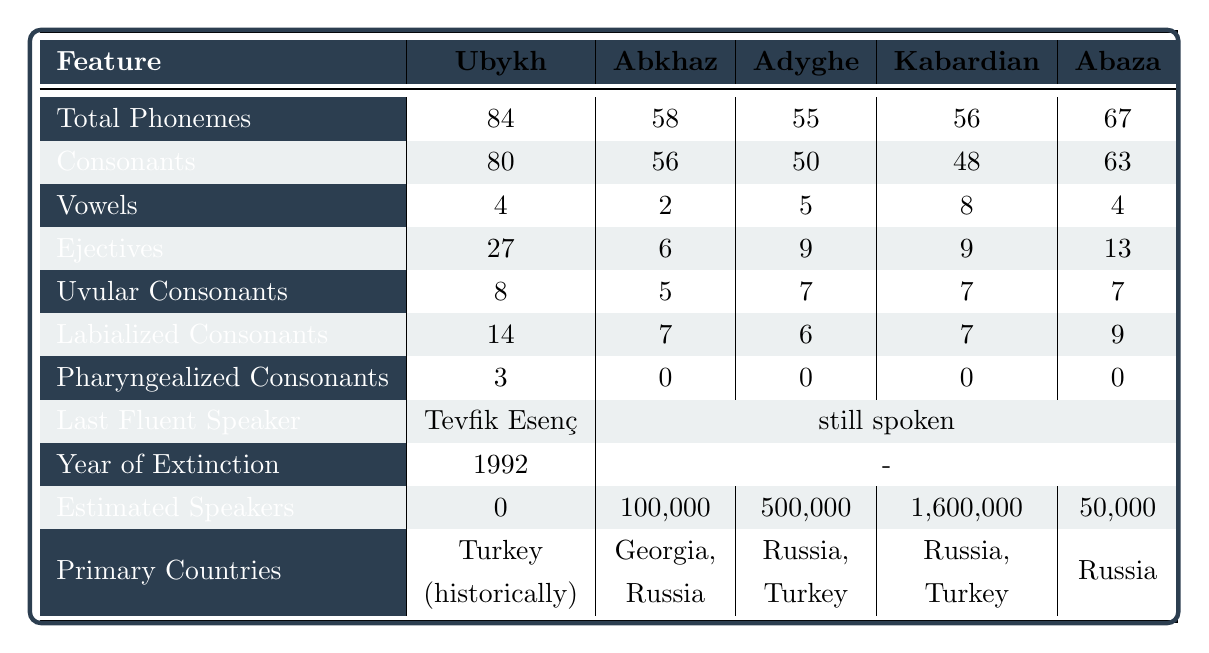What is the total number of phonemes in Ubykh? According to the table, Ubykh has a total of 84 phonemes listed under the "Total Phonemes" column.
Answer: 84 How many consonants does Abkhaz have? The table shows that Abkhaz has 56 consonants listed under the "Consonants" column.
Answer: 56 Which language has the most estimated speakers? By examining the "Estimated Speakers" column, Kabardian has the highest number of estimated speakers, with 1,600,000.
Answer: Kabardian What is the total number of vowels in Adyghe? The total number of vowels in Adyghe, as seen in the "Vowels" column, is 5.
Answer: 5 Which language has the highest number of ejectives? Looking at the "Ejectives" column, Ubykh has the highest count with 27 ejectives.
Answer: Ubykh Is Abaza still spoken? According to the "Last Fluent Speaker" row, Abaza is listed as still spoken.
Answer: Yes How many total phonemes are there when combining the total phonemes of Abkhaz and Abaza? Adding the total phonemes of Abkhaz (58) and Abaza (67) gives us 58 + 67 = 125 Total Phonemes.
Answer: 125 Which language has more labialized consonants, Kabardian or Abzak? Comparing the "Labialized Consonants" column, Abaza (9) has more than Kabardian (7).
Answer: Abaza What is the average number of vowels across all languages listed? The total number of vowels is (4 + 2 + 5 + 8 + 4) = 23, and there are 5 languages, so the average is 23/5 = 4.6.
Answer: 4.6 Are there any pharyngealized consonants in Abkhaz? According to the "Pharyngealized Consonants" row, Abkhaz has 0 pharyngealized consonants listed.
Answer: No How many more consonants does Ubykh have compared to Adyghe? Ubykh has 80 consonants and Adyghe has 50, so the difference is 80 - 50 = 30 more consonants.
Answer: 30 